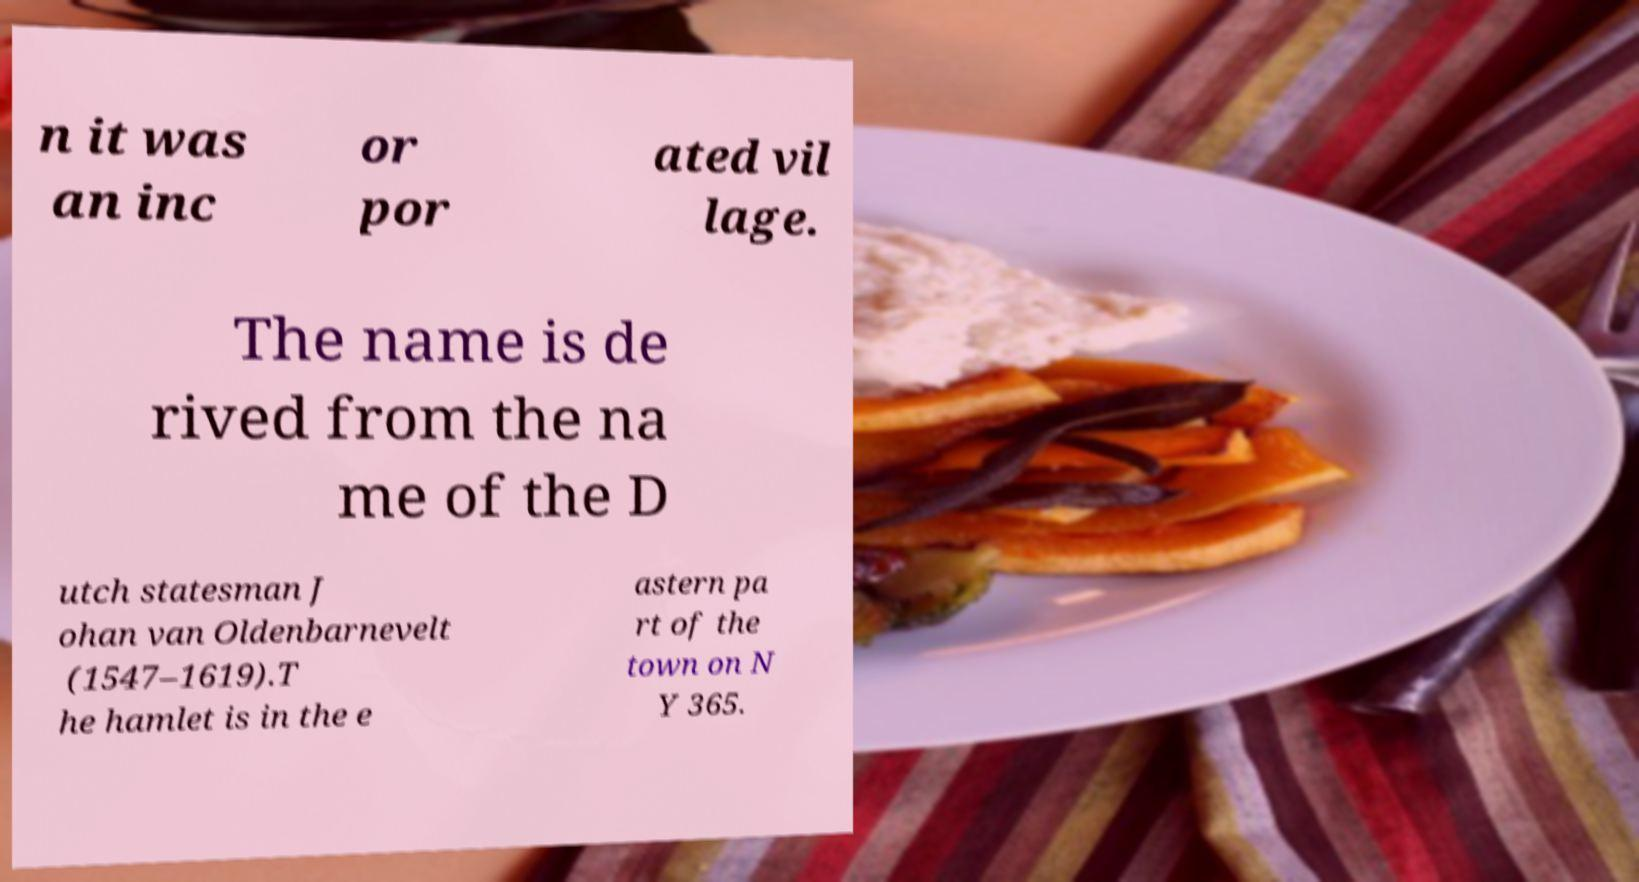Could you extract and type out the text from this image? n it was an inc or por ated vil lage. The name is de rived from the na me of the D utch statesman J ohan van Oldenbarnevelt (1547–1619).T he hamlet is in the e astern pa rt of the town on N Y 365. 